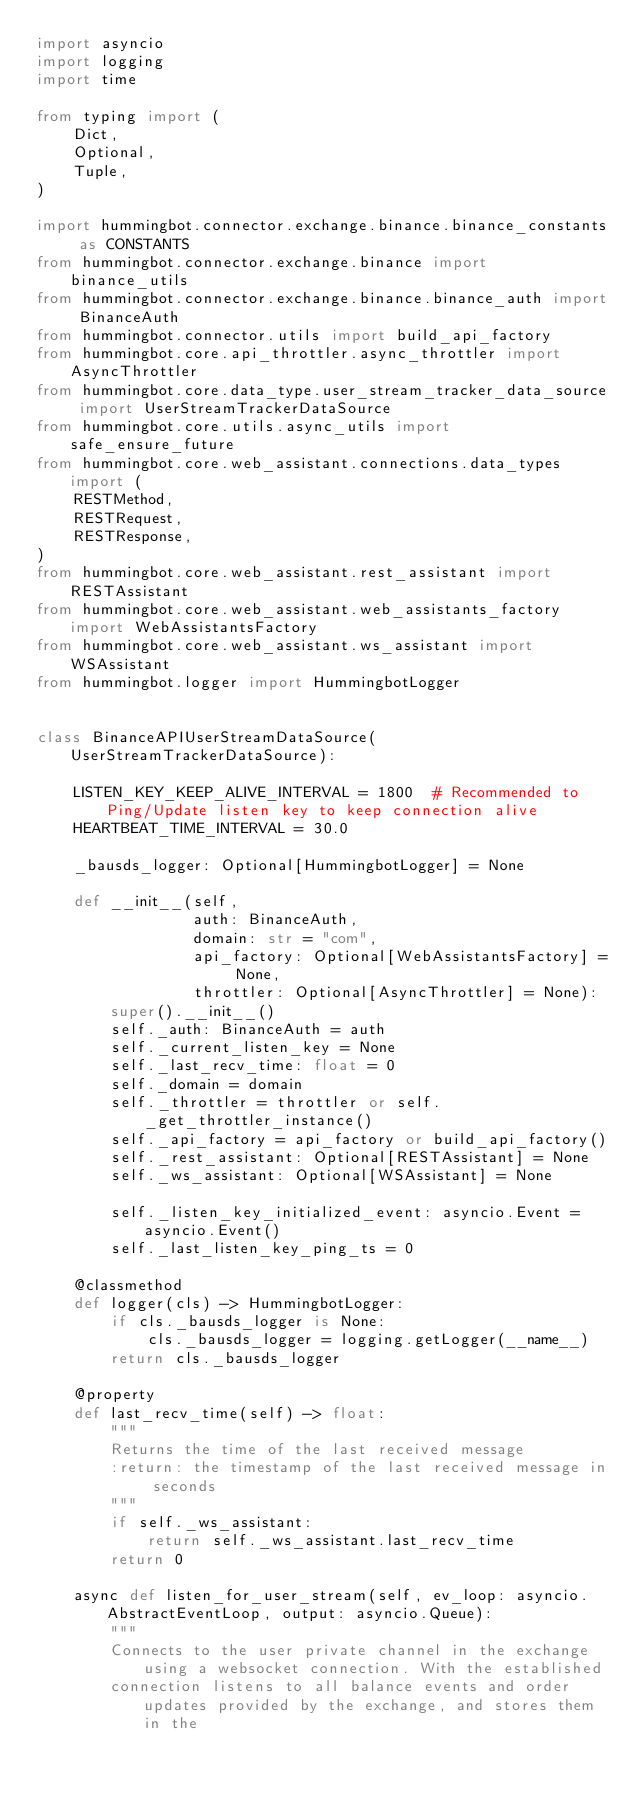<code> <loc_0><loc_0><loc_500><loc_500><_Python_>import asyncio
import logging
import time

from typing import (
    Dict,
    Optional,
    Tuple,
)

import hummingbot.connector.exchange.binance.binance_constants as CONSTANTS
from hummingbot.connector.exchange.binance import binance_utils
from hummingbot.connector.exchange.binance.binance_auth import BinanceAuth
from hummingbot.connector.utils import build_api_factory
from hummingbot.core.api_throttler.async_throttler import AsyncThrottler
from hummingbot.core.data_type.user_stream_tracker_data_source import UserStreamTrackerDataSource
from hummingbot.core.utils.async_utils import safe_ensure_future
from hummingbot.core.web_assistant.connections.data_types import (
    RESTMethod,
    RESTRequest,
    RESTResponse,
)
from hummingbot.core.web_assistant.rest_assistant import RESTAssistant
from hummingbot.core.web_assistant.web_assistants_factory import WebAssistantsFactory
from hummingbot.core.web_assistant.ws_assistant import WSAssistant
from hummingbot.logger import HummingbotLogger


class BinanceAPIUserStreamDataSource(UserStreamTrackerDataSource):

    LISTEN_KEY_KEEP_ALIVE_INTERVAL = 1800  # Recommended to Ping/Update listen key to keep connection alive
    HEARTBEAT_TIME_INTERVAL = 30.0

    _bausds_logger: Optional[HummingbotLogger] = None

    def __init__(self,
                 auth: BinanceAuth,
                 domain: str = "com",
                 api_factory: Optional[WebAssistantsFactory] = None,
                 throttler: Optional[AsyncThrottler] = None):
        super().__init__()
        self._auth: BinanceAuth = auth
        self._current_listen_key = None
        self._last_recv_time: float = 0
        self._domain = domain
        self._throttler = throttler or self._get_throttler_instance()
        self._api_factory = api_factory or build_api_factory()
        self._rest_assistant: Optional[RESTAssistant] = None
        self._ws_assistant: Optional[WSAssistant] = None

        self._listen_key_initialized_event: asyncio.Event = asyncio.Event()
        self._last_listen_key_ping_ts = 0

    @classmethod
    def logger(cls) -> HummingbotLogger:
        if cls._bausds_logger is None:
            cls._bausds_logger = logging.getLogger(__name__)
        return cls._bausds_logger

    @property
    def last_recv_time(self) -> float:
        """
        Returns the time of the last received message
        :return: the timestamp of the last received message in seconds
        """
        if self._ws_assistant:
            return self._ws_assistant.last_recv_time
        return 0

    async def listen_for_user_stream(self, ev_loop: asyncio.AbstractEventLoop, output: asyncio.Queue):
        """
        Connects to the user private channel in the exchange using a websocket connection. With the established
        connection listens to all balance events and order updates provided by the exchange, and stores them in the</code> 